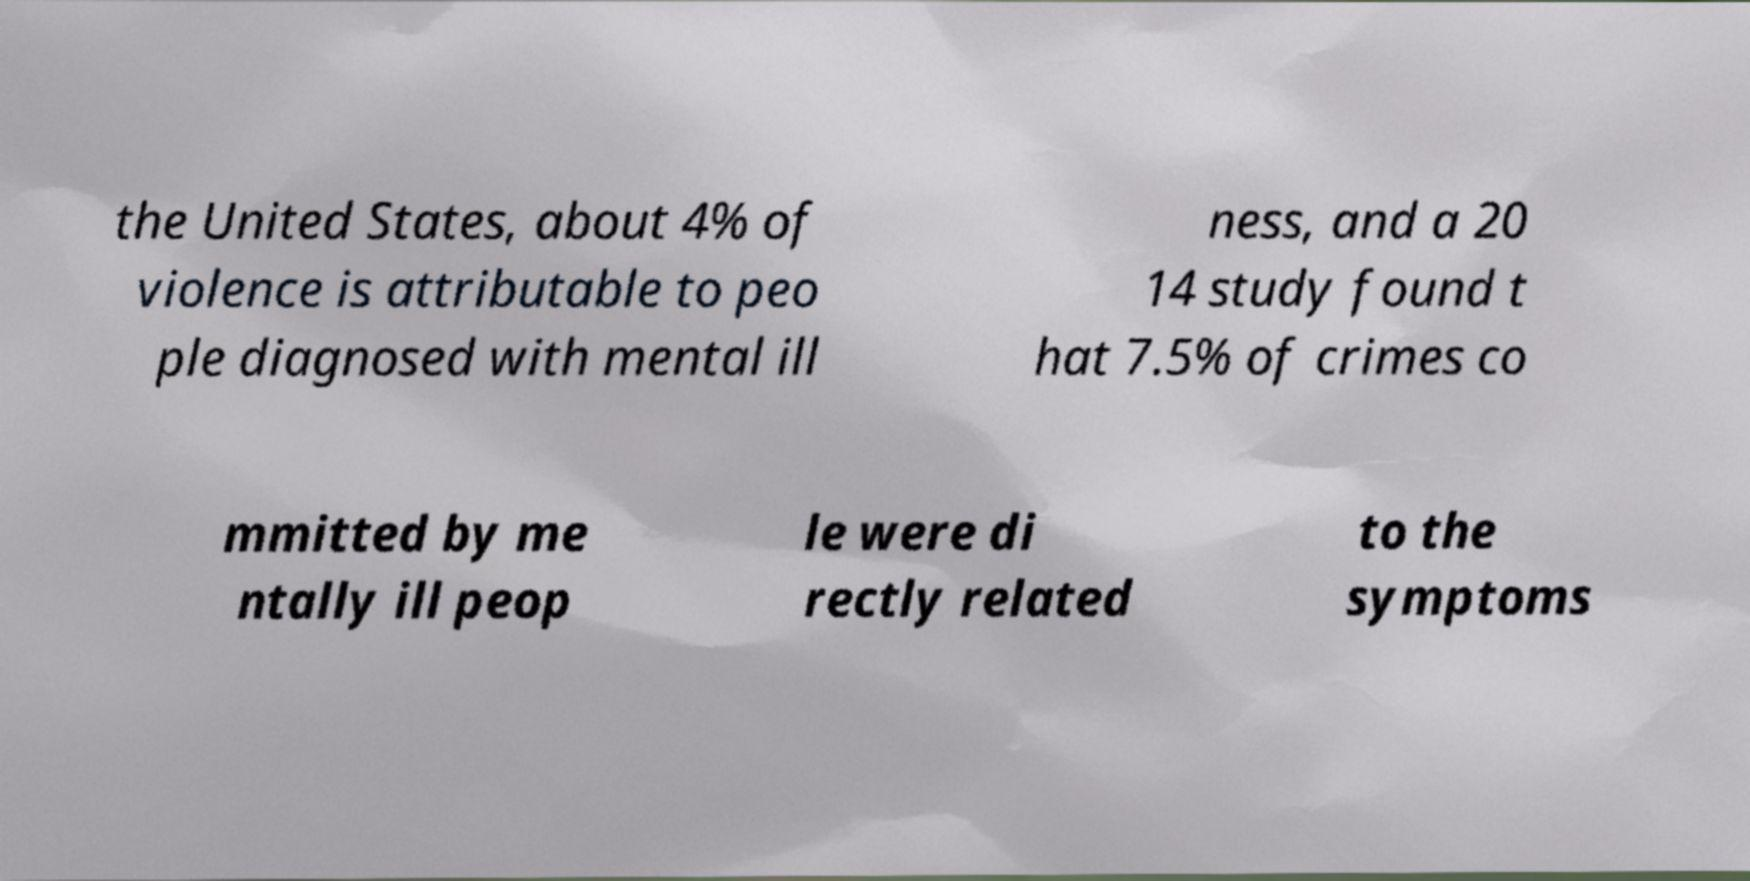Could you assist in decoding the text presented in this image and type it out clearly? the United States, about 4% of violence is attributable to peo ple diagnosed with mental ill ness, and a 20 14 study found t hat 7.5% of crimes co mmitted by me ntally ill peop le were di rectly related to the symptoms 